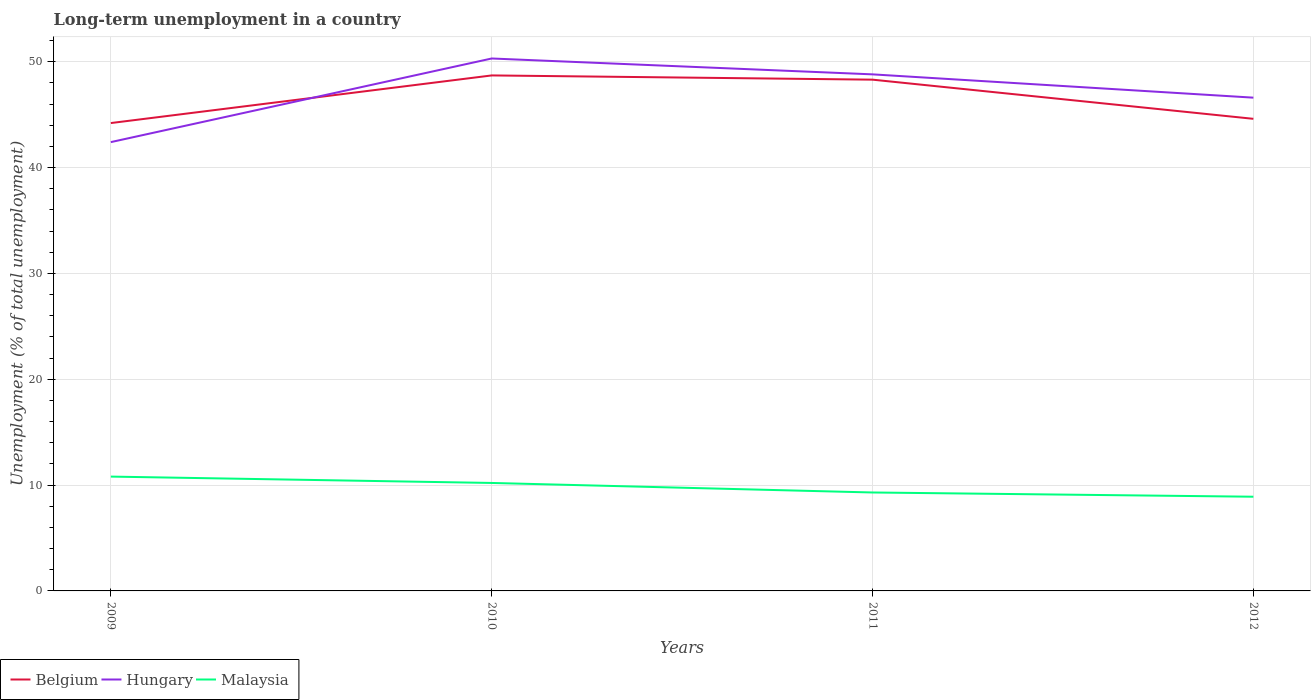Does the line corresponding to Malaysia intersect with the line corresponding to Hungary?
Your answer should be very brief. No. Across all years, what is the maximum percentage of long-term unemployed population in Belgium?
Make the answer very short. 44.2. In which year was the percentage of long-term unemployed population in Malaysia maximum?
Keep it short and to the point. 2012. What is the total percentage of long-term unemployed population in Hungary in the graph?
Your answer should be very brief. -6.4. What is the difference between the highest and the second highest percentage of long-term unemployed population in Hungary?
Provide a succinct answer. 7.9. How many lines are there?
Your answer should be compact. 3. How many years are there in the graph?
Make the answer very short. 4. What is the difference between two consecutive major ticks on the Y-axis?
Ensure brevity in your answer.  10. Are the values on the major ticks of Y-axis written in scientific E-notation?
Offer a very short reply. No. Does the graph contain any zero values?
Give a very brief answer. No. What is the title of the graph?
Give a very brief answer. Long-term unemployment in a country. What is the label or title of the X-axis?
Your answer should be compact. Years. What is the label or title of the Y-axis?
Your response must be concise. Unemployment (% of total unemployment). What is the Unemployment (% of total unemployment) in Belgium in 2009?
Your response must be concise. 44.2. What is the Unemployment (% of total unemployment) in Hungary in 2009?
Offer a very short reply. 42.4. What is the Unemployment (% of total unemployment) in Malaysia in 2009?
Make the answer very short. 10.8. What is the Unemployment (% of total unemployment) of Belgium in 2010?
Give a very brief answer. 48.7. What is the Unemployment (% of total unemployment) in Hungary in 2010?
Offer a terse response. 50.3. What is the Unemployment (% of total unemployment) in Malaysia in 2010?
Offer a very short reply. 10.2. What is the Unemployment (% of total unemployment) in Belgium in 2011?
Your answer should be compact. 48.3. What is the Unemployment (% of total unemployment) of Hungary in 2011?
Offer a terse response. 48.8. What is the Unemployment (% of total unemployment) of Malaysia in 2011?
Ensure brevity in your answer.  9.3. What is the Unemployment (% of total unemployment) in Belgium in 2012?
Your answer should be compact. 44.6. What is the Unemployment (% of total unemployment) of Hungary in 2012?
Provide a short and direct response. 46.6. What is the Unemployment (% of total unemployment) in Malaysia in 2012?
Provide a short and direct response. 8.9. Across all years, what is the maximum Unemployment (% of total unemployment) in Belgium?
Give a very brief answer. 48.7. Across all years, what is the maximum Unemployment (% of total unemployment) in Hungary?
Provide a succinct answer. 50.3. Across all years, what is the maximum Unemployment (% of total unemployment) of Malaysia?
Ensure brevity in your answer.  10.8. Across all years, what is the minimum Unemployment (% of total unemployment) in Belgium?
Offer a terse response. 44.2. Across all years, what is the minimum Unemployment (% of total unemployment) in Hungary?
Give a very brief answer. 42.4. Across all years, what is the minimum Unemployment (% of total unemployment) in Malaysia?
Keep it short and to the point. 8.9. What is the total Unemployment (% of total unemployment) of Belgium in the graph?
Provide a succinct answer. 185.8. What is the total Unemployment (% of total unemployment) of Hungary in the graph?
Offer a terse response. 188.1. What is the total Unemployment (% of total unemployment) of Malaysia in the graph?
Keep it short and to the point. 39.2. What is the difference between the Unemployment (% of total unemployment) in Malaysia in 2009 and that in 2010?
Give a very brief answer. 0.6. What is the difference between the Unemployment (% of total unemployment) of Belgium in 2009 and that in 2011?
Make the answer very short. -4.1. What is the difference between the Unemployment (% of total unemployment) in Hungary in 2009 and that in 2011?
Provide a succinct answer. -6.4. What is the difference between the Unemployment (% of total unemployment) of Malaysia in 2009 and that in 2011?
Give a very brief answer. 1.5. What is the difference between the Unemployment (% of total unemployment) of Belgium in 2010 and that in 2012?
Offer a terse response. 4.1. What is the difference between the Unemployment (% of total unemployment) in Hungary in 2010 and that in 2012?
Offer a very short reply. 3.7. What is the difference between the Unemployment (% of total unemployment) of Malaysia in 2010 and that in 2012?
Provide a succinct answer. 1.3. What is the difference between the Unemployment (% of total unemployment) in Belgium in 2011 and that in 2012?
Offer a very short reply. 3.7. What is the difference between the Unemployment (% of total unemployment) in Belgium in 2009 and the Unemployment (% of total unemployment) in Hungary in 2010?
Your response must be concise. -6.1. What is the difference between the Unemployment (% of total unemployment) in Belgium in 2009 and the Unemployment (% of total unemployment) in Malaysia in 2010?
Provide a succinct answer. 34. What is the difference between the Unemployment (% of total unemployment) in Hungary in 2009 and the Unemployment (% of total unemployment) in Malaysia in 2010?
Offer a terse response. 32.2. What is the difference between the Unemployment (% of total unemployment) of Belgium in 2009 and the Unemployment (% of total unemployment) of Hungary in 2011?
Provide a succinct answer. -4.6. What is the difference between the Unemployment (% of total unemployment) of Belgium in 2009 and the Unemployment (% of total unemployment) of Malaysia in 2011?
Give a very brief answer. 34.9. What is the difference between the Unemployment (% of total unemployment) of Hungary in 2009 and the Unemployment (% of total unemployment) of Malaysia in 2011?
Your answer should be compact. 33.1. What is the difference between the Unemployment (% of total unemployment) of Belgium in 2009 and the Unemployment (% of total unemployment) of Hungary in 2012?
Keep it short and to the point. -2.4. What is the difference between the Unemployment (% of total unemployment) in Belgium in 2009 and the Unemployment (% of total unemployment) in Malaysia in 2012?
Provide a short and direct response. 35.3. What is the difference between the Unemployment (% of total unemployment) of Hungary in 2009 and the Unemployment (% of total unemployment) of Malaysia in 2012?
Provide a succinct answer. 33.5. What is the difference between the Unemployment (% of total unemployment) of Belgium in 2010 and the Unemployment (% of total unemployment) of Malaysia in 2011?
Provide a succinct answer. 39.4. What is the difference between the Unemployment (% of total unemployment) in Hungary in 2010 and the Unemployment (% of total unemployment) in Malaysia in 2011?
Ensure brevity in your answer.  41. What is the difference between the Unemployment (% of total unemployment) of Belgium in 2010 and the Unemployment (% of total unemployment) of Malaysia in 2012?
Make the answer very short. 39.8. What is the difference between the Unemployment (% of total unemployment) in Hungary in 2010 and the Unemployment (% of total unemployment) in Malaysia in 2012?
Your answer should be compact. 41.4. What is the difference between the Unemployment (% of total unemployment) in Belgium in 2011 and the Unemployment (% of total unemployment) in Malaysia in 2012?
Offer a very short reply. 39.4. What is the difference between the Unemployment (% of total unemployment) in Hungary in 2011 and the Unemployment (% of total unemployment) in Malaysia in 2012?
Your answer should be compact. 39.9. What is the average Unemployment (% of total unemployment) in Belgium per year?
Keep it short and to the point. 46.45. What is the average Unemployment (% of total unemployment) in Hungary per year?
Keep it short and to the point. 47.02. What is the average Unemployment (% of total unemployment) in Malaysia per year?
Keep it short and to the point. 9.8. In the year 2009, what is the difference between the Unemployment (% of total unemployment) in Belgium and Unemployment (% of total unemployment) in Malaysia?
Your response must be concise. 33.4. In the year 2009, what is the difference between the Unemployment (% of total unemployment) in Hungary and Unemployment (% of total unemployment) in Malaysia?
Ensure brevity in your answer.  31.6. In the year 2010, what is the difference between the Unemployment (% of total unemployment) in Belgium and Unemployment (% of total unemployment) in Malaysia?
Your answer should be compact. 38.5. In the year 2010, what is the difference between the Unemployment (% of total unemployment) in Hungary and Unemployment (% of total unemployment) in Malaysia?
Offer a terse response. 40.1. In the year 2011, what is the difference between the Unemployment (% of total unemployment) of Belgium and Unemployment (% of total unemployment) of Hungary?
Give a very brief answer. -0.5. In the year 2011, what is the difference between the Unemployment (% of total unemployment) of Hungary and Unemployment (% of total unemployment) of Malaysia?
Offer a terse response. 39.5. In the year 2012, what is the difference between the Unemployment (% of total unemployment) of Belgium and Unemployment (% of total unemployment) of Malaysia?
Your response must be concise. 35.7. In the year 2012, what is the difference between the Unemployment (% of total unemployment) of Hungary and Unemployment (% of total unemployment) of Malaysia?
Offer a terse response. 37.7. What is the ratio of the Unemployment (% of total unemployment) of Belgium in 2009 to that in 2010?
Keep it short and to the point. 0.91. What is the ratio of the Unemployment (% of total unemployment) of Hungary in 2009 to that in 2010?
Provide a succinct answer. 0.84. What is the ratio of the Unemployment (% of total unemployment) of Malaysia in 2009 to that in 2010?
Offer a very short reply. 1.06. What is the ratio of the Unemployment (% of total unemployment) in Belgium in 2009 to that in 2011?
Ensure brevity in your answer.  0.92. What is the ratio of the Unemployment (% of total unemployment) of Hungary in 2009 to that in 2011?
Offer a terse response. 0.87. What is the ratio of the Unemployment (% of total unemployment) in Malaysia in 2009 to that in 2011?
Your answer should be compact. 1.16. What is the ratio of the Unemployment (% of total unemployment) of Hungary in 2009 to that in 2012?
Make the answer very short. 0.91. What is the ratio of the Unemployment (% of total unemployment) of Malaysia in 2009 to that in 2012?
Your answer should be compact. 1.21. What is the ratio of the Unemployment (% of total unemployment) in Belgium in 2010 to that in 2011?
Your answer should be compact. 1.01. What is the ratio of the Unemployment (% of total unemployment) in Hungary in 2010 to that in 2011?
Give a very brief answer. 1.03. What is the ratio of the Unemployment (% of total unemployment) in Malaysia in 2010 to that in 2011?
Your response must be concise. 1.1. What is the ratio of the Unemployment (% of total unemployment) of Belgium in 2010 to that in 2012?
Ensure brevity in your answer.  1.09. What is the ratio of the Unemployment (% of total unemployment) of Hungary in 2010 to that in 2012?
Keep it short and to the point. 1.08. What is the ratio of the Unemployment (% of total unemployment) of Malaysia in 2010 to that in 2012?
Ensure brevity in your answer.  1.15. What is the ratio of the Unemployment (% of total unemployment) in Belgium in 2011 to that in 2012?
Your answer should be compact. 1.08. What is the ratio of the Unemployment (% of total unemployment) in Hungary in 2011 to that in 2012?
Your answer should be compact. 1.05. What is the ratio of the Unemployment (% of total unemployment) of Malaysia in 2011 to that in 2012?
Your response must be concise. 1.04. What is the difference between the highest and the second highest Unemployment (% of total unemployment) of Belgium?
Make the answer very short. 0.4. What is the difference between the highest and the second highest Unemployment (% of total unemployment) in Malaysia?
Provide a short and direct response. 0.6. What is the difference between the highest and the lowest Unemployment (% of total unemployment) in Belgium?
Offer a very short reply. 4.5. 